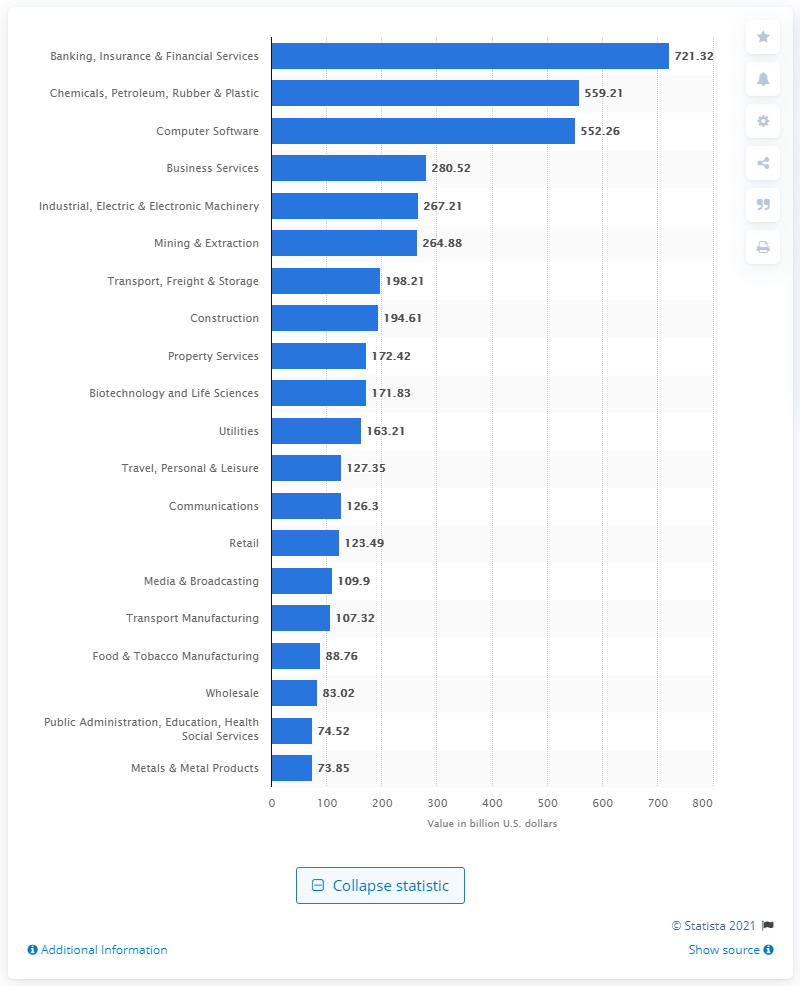Draw attention to some important aspects in this diagram. In 2019, the value of M&A deals in the banking, insurance, and financial services sector reached $721.32 billion. 